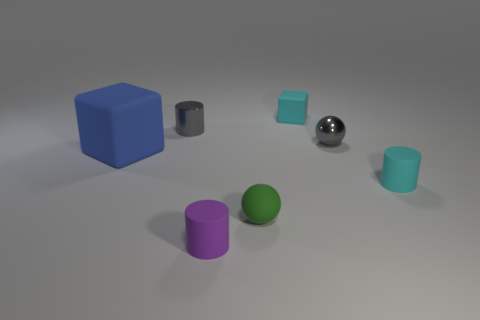How does the lighting in the scene affect the appearance of the objects? The lighting appears to be soft and diffused, casting gentle shadows and giving the objects a smooth appearance. It enhances the three-dimensional feel of the objects while avoiding harsh reflections, except on the shiny sphere where a bright highlight showcases its reflective surface. Which object seems to be the most reflective? The sphere in the center has the most reflective surface, as evidenced by the clear highlight and the visible reflections of the environment on it. 